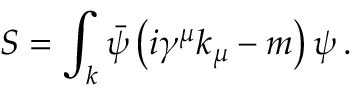Convert formula to latex. <formula><loc_0><loc_0><loc_500><loc_500>S = \int _ { k } { \bar { \psi } } \left ( i \gamma ^ { \mu } k _ { \mu } - m \right ) \psi \, .</formula> 